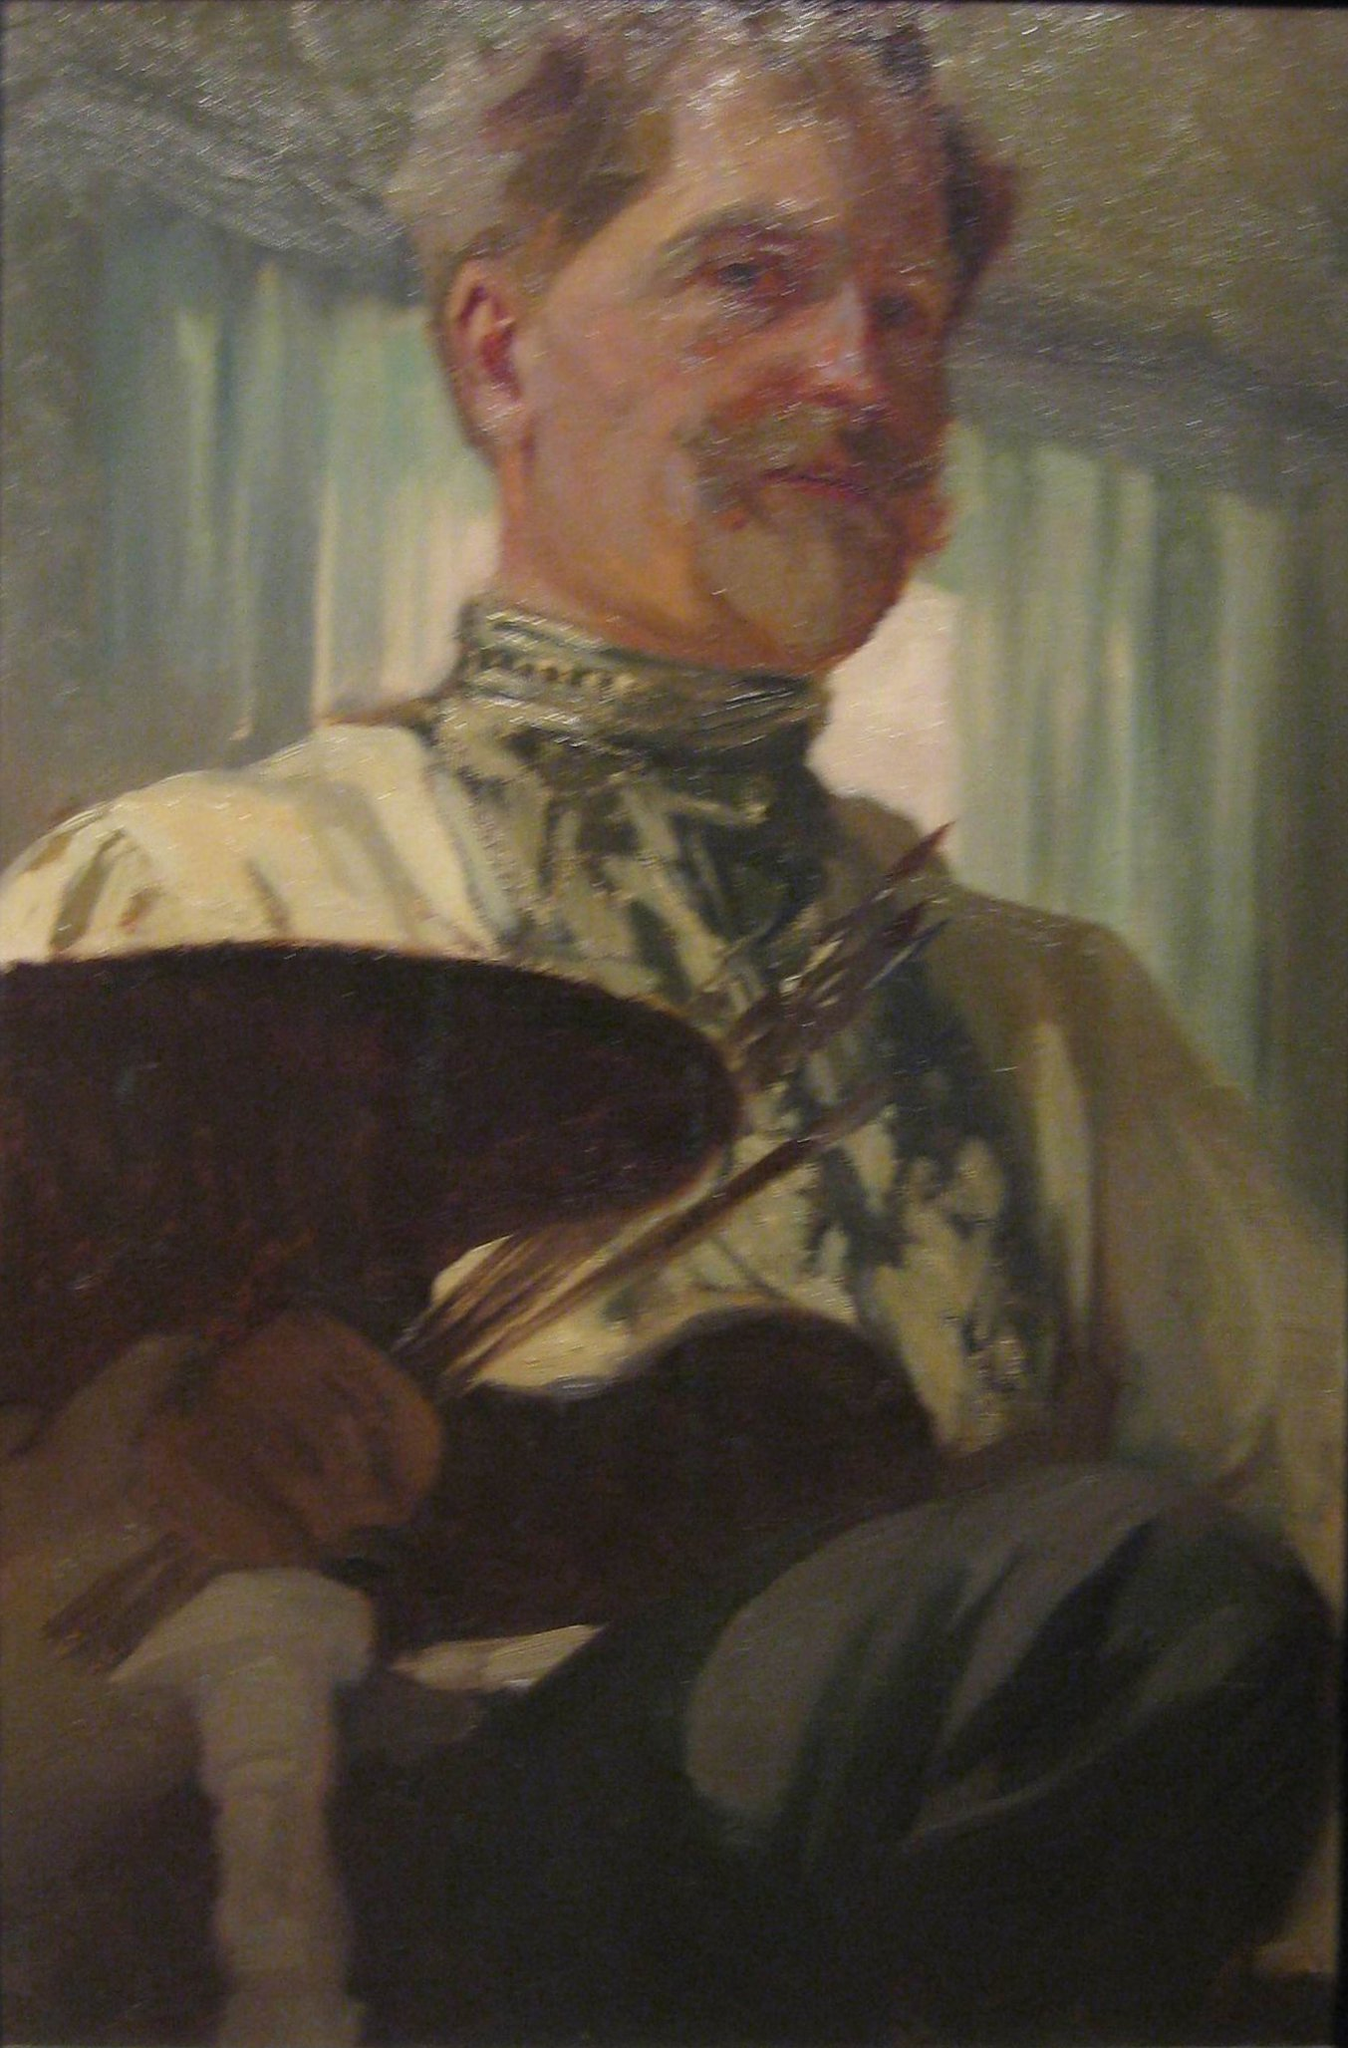What can you infer about the man’s profession and personality based on the visual elements of the image? Based on the visual elements in the image, the man appears to be an artist, specifically a painter. This inference can be drawn from his attire, which includes a distinctive artist’s smock with a high, ornate collar, and from his holding of an artist's palette laden with paints and a cluster of paintbrushes. His facial expression and the slightly disheveled state of his hair suggest a person deeply immersed in his craft, possibly caught in a moment of creative focus. The warm tones and soft background lend a sense of calmness and introspection, implying a personality that may be reflective and dedicated to his art. The detailed depiction of his face and attire demonstrates not only his professional role but also suggests a level of prestige and respect in his field. 